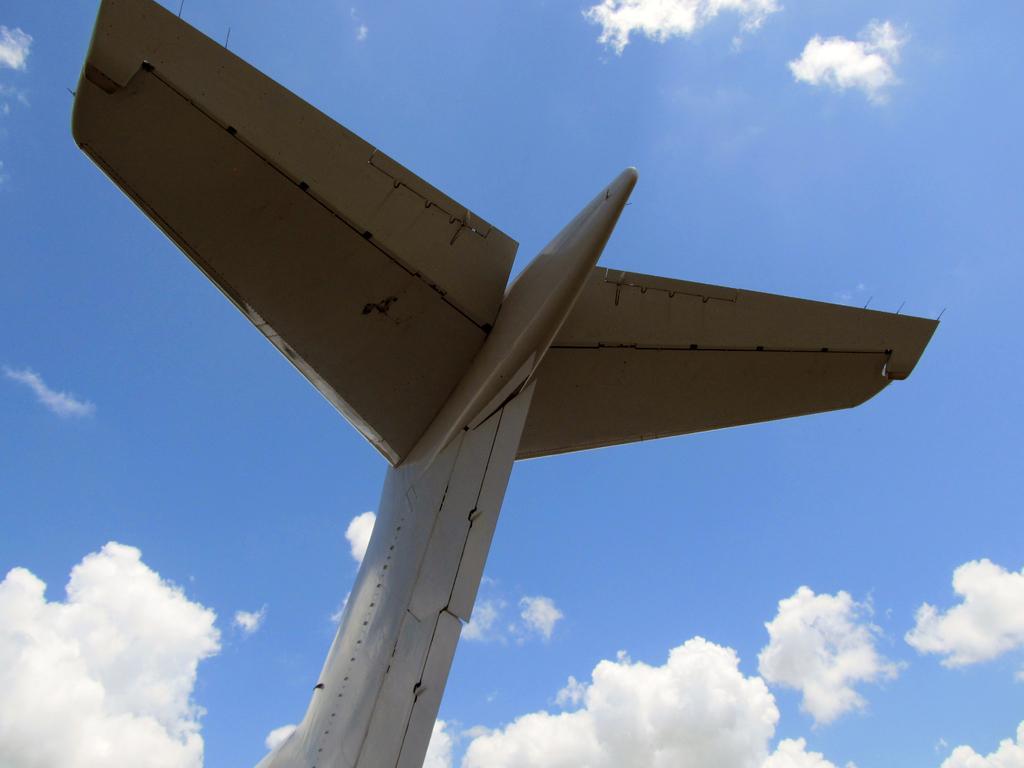Could you give a brief overview of what you see in this image? In this image we can see the wings of an aircraft. This is a sky with clouds. 